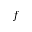Convert formula to latex. <formula><loc_0><loc_0><loc_500><loc_500>f</formula> 